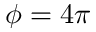<formula> <loc_0><loc_0><loc_500><loc_500>\phi = 4 \pi</formula> 